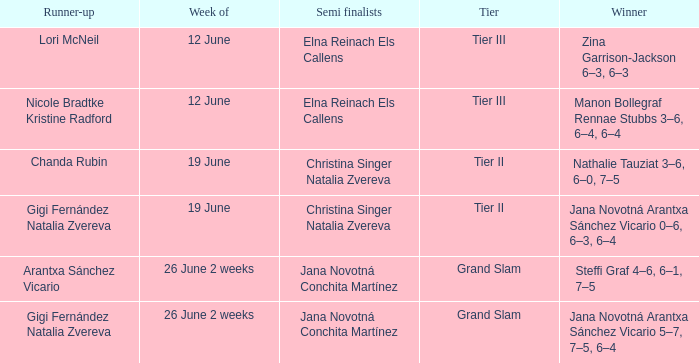Who are the semi finalists on the week of 12 june, when the runner-up is listed as Lori McNeil? Elna Reinach Els Callens. 